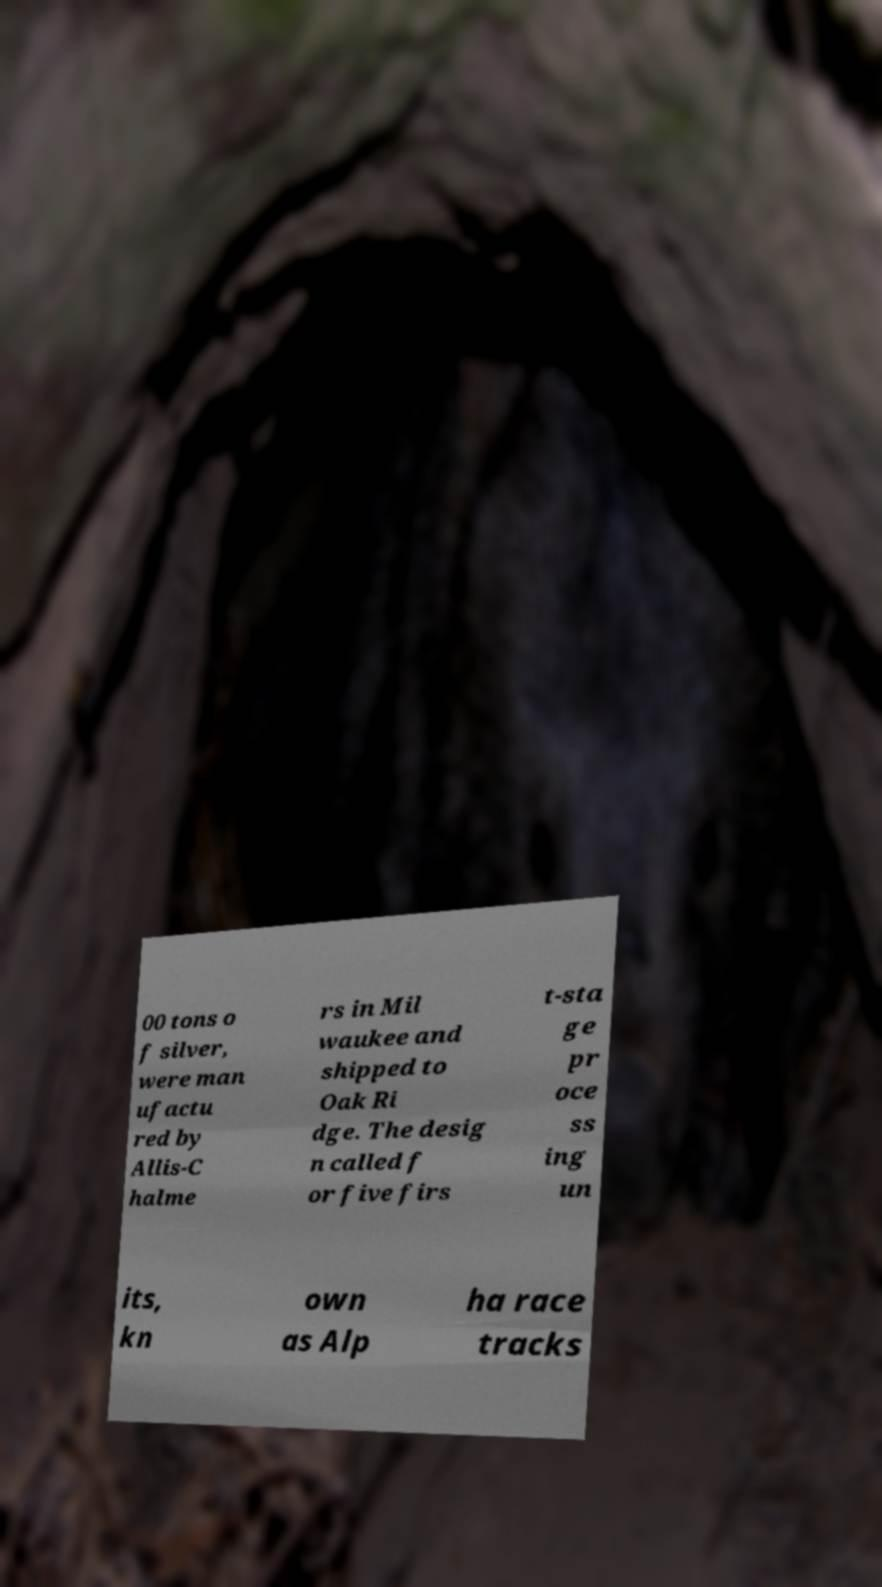Can you read and provide the text displayed in the image?This photo seems to have some interesting text. Can you extract and type it out for me? 00 tons o f silver, were man ufactu red by Allis-C halme rs in Mil waukee and shipped to Oak Ri dge. The desig n called f or five firs t-sta ge pr oce ss ing un its, kn own as Alp ha race tracks 